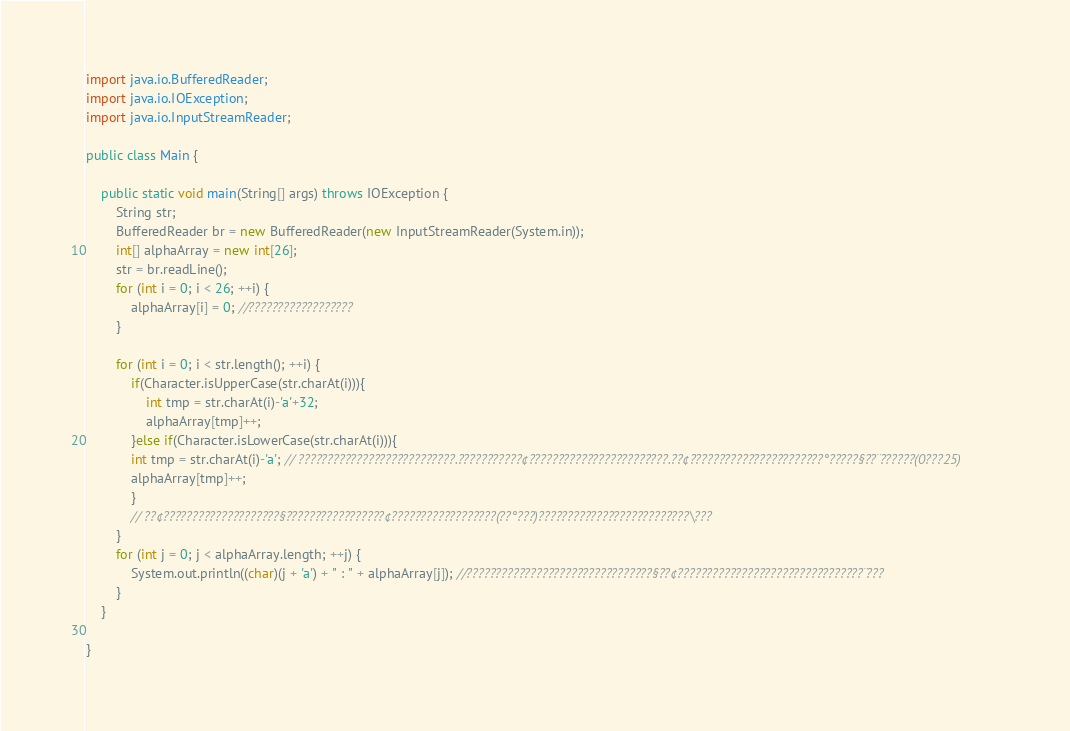Convert code to text. <code><loc_0><loc_0><loc_500><loc_500><_Java_>import java.io.BufferedReader;
import java.io.IOException;
import java.io.InputStreamReader;

public class Main {

	public static void main(String[] args) throws IOException {
		String str;
		BufferedReader br = new BufferedReader(new InputStreamReader(System.in));
		int[] alphaArray = new int[26];
		str = br.readLine();
		for (int i = 0; i < 26; ++i) {
			alphaArray[i] = 0; //??????????????????
		}

		for (int i = 0; i < str.length(); ++i) {
			if(Character.isUpperCase(str.charAt(i))){
				int tmp = str.charAt(i)-'a'+32;
				alphaArray[tmp]++;
			}else if(Character.isLowerCase(str.charAt(i))){
			int tmp = str.charAt(i)-'a'; // ???????????????????????????.???????????¢????????????????????????.??¢???????????????????????°?????§??¨??????(0???25)
			alphaArray[tmp]++;
			}
			// ??¢????????????????????§?????????????????¢??????????????????(??°???)??????????????????????????\???
		}
		for (int j = 0; j < alphaArray.length; ++j) {
			System.out.println((char)(j + 'a') + " : " + alphaArray[j]); //????????????????????????????????§??¢????????????????????????????????¨???
		}
	}

}</code> 